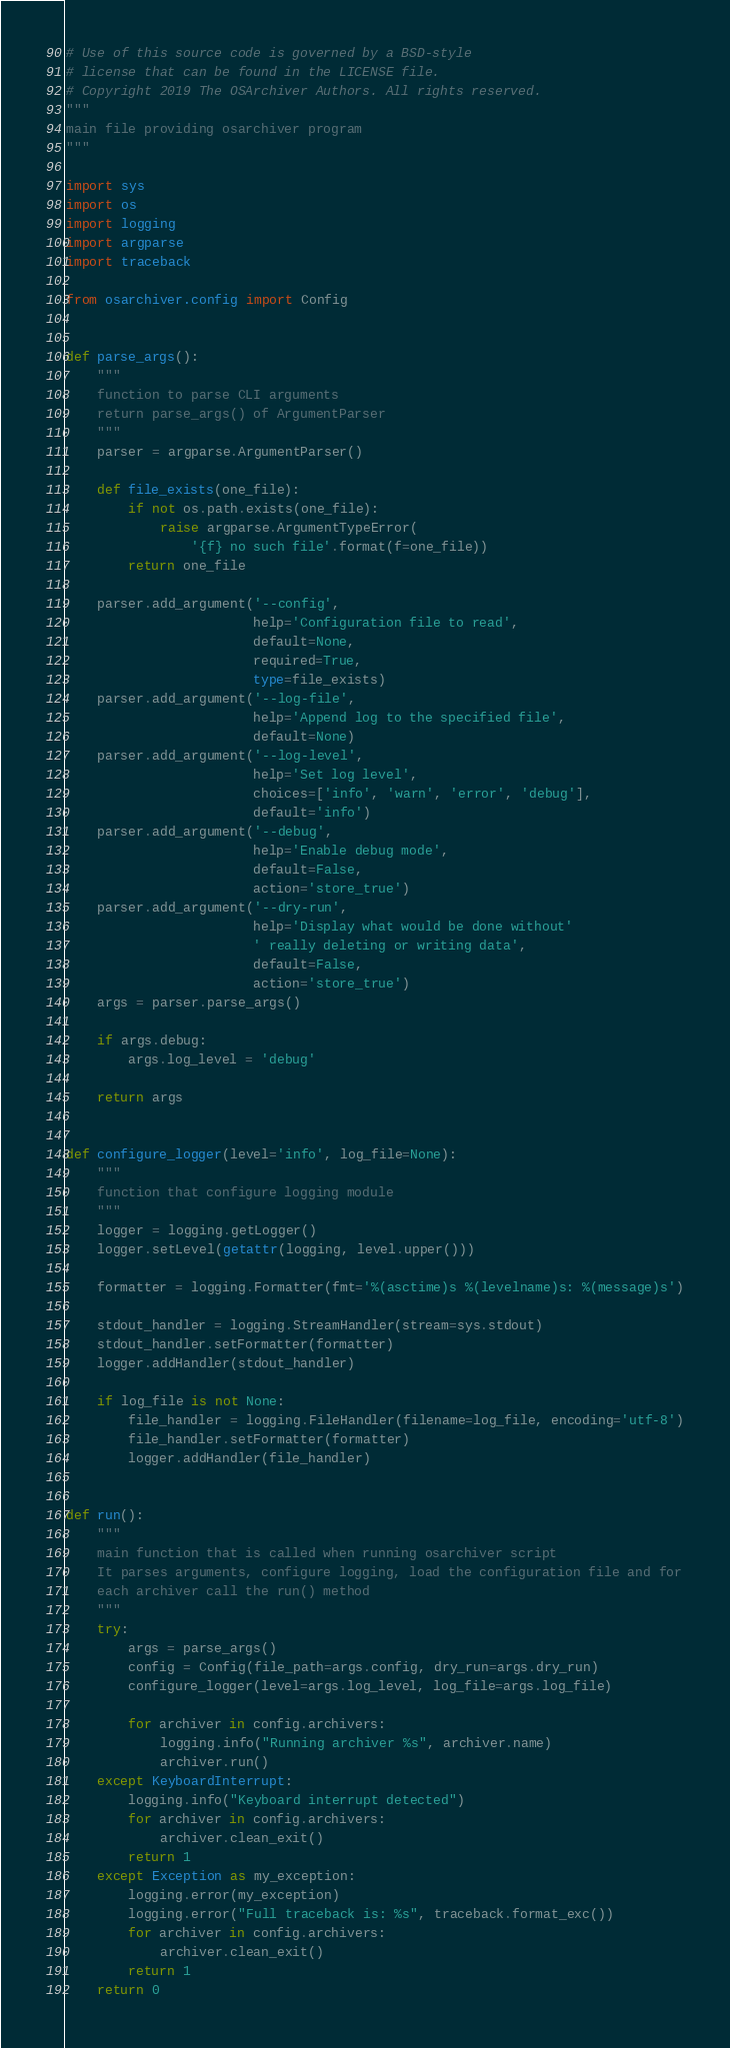<code> <loc_0><loc_0><loc_500><loc_500><_Python_># Use of this source code is governed by a BSD-style
# license that can be found in the LICENSE file.
# Copyright 2019 The OSArchiver Authors. All rights reserved.
"""
main file providing osarchiver program
"""

import sys
import os
import logging
import argparse
import traceback

from osarchiver.config import Config


def parse_args():
    """
    function to parse CLI arguments
    return parse_args() of ArgumentParser
    """
    parser = argparse.ArgumentParser()

    def file_exists(one_file):
        if not os.path.exists(one_file):
            raise argparse.ArgumentTypeError(
                '{f} no such file'.format(f=one_file))
        return one_file

    parser.add_argument('--config',
                        help='Configuration file to read',
                        default=None,
                        required=True,
                        type=file_exists)
    parser.add_argument('--log-file',
                        help='Append log to the specified file',
                        default=None)
    parser.add_argument('--log-level',
                        help='Set log level',
                        choices=['info', 'warn', 'error', 'debug'],
                        default='info')
    parser.add_argument('--debug',
                        help='Enable debug mode',
                        default=False,
                        action='store_true')
    parser.add_argument('--dry-run',
                        help='Display what would be done without'
                        ' really deleting or writing data',
                        default=False,
                        action='store_true')
    args = parser.parse_args()

    if args.debug:
        args.log_level = 'debug'

    return args


def configure_logger(level='info', log_file=None):
    """
    function that configure logging module
    """
    logger = logging.getLogger()
    logger.setLevel(getattr(logging, level.upper()))

    formatter = logging.Formatter(fmt='%(asctime)s %(levelname)s: %(message)s')

    stdout_handler = logging.StreamHandler(stream=sys.stdout)
    stdout_handler.setFormatter(formatter)
    logger.addHandler(stdout_handler)

    if log_file is not None:
        file_handler = logging.FileHandler(filename=log_file, encoding='utf-8')
        file_handler.setFormatter(formatter)
        logger.addHandler(file_handler)


def run():
    """
    main function that is called when running osarchiver script
    It parses arguments, configure logging, load the configuration file and for
    each archiver call the run() method
    """
    try:
        args = parse_args()
        config = Config(file_path=args.config, dry_run=args.dry_run)
        configure_logger(level=args.log_level, log_file=args.log_file)

        for archiver in config.archivers:
            logging.info("Running archiver %s", archiver.name)
            archiver.run()
    except KeyboardInterrupt:
        logging.info("Keyboard interrupt detected")
        for archiver in config.archivers:
            archiver.clean_exit()
        return 1
    except Exception as my_exception:
        logging.error(my_exception)
        logging.error("Full traceback is: %s", traceback.format_exc())
        for archiver in config.archivers:
            archiver.clean_exit()
        return 1
    return 0
</code> 